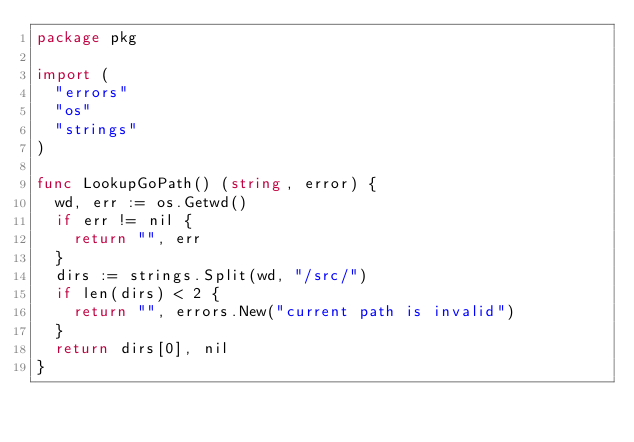Convert code to text. <code><loc_0><loc_0><loc_500><loc_500><_Go_>package pkg

import (
	"errors"
	"os"
	"strings"
)

func LookupGoPath() (string, error) {
	wd, err := os.Getwd()
	if err != nil {
		return "", err
	}
	dirs := strings.Split(wd, "/src/")
	if len(dirs) < 2 {
		return "", errors.New("current path is invalid")
	}
	return dirs[0], nil
}
</code> 